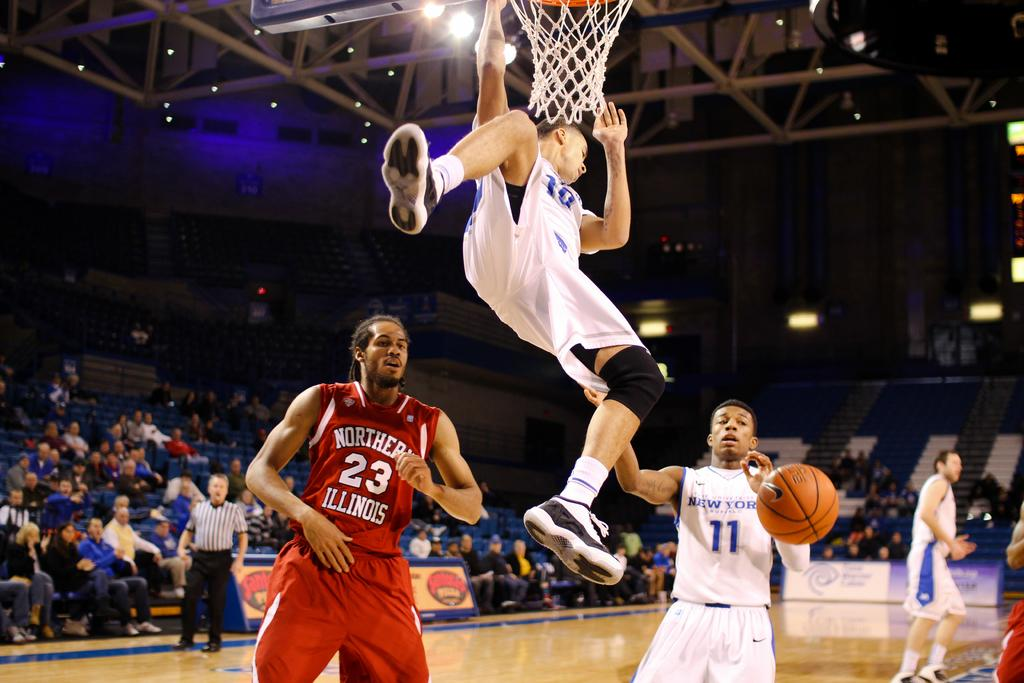<image>
Give a short and clear explanation of the subsequent image. a person standing with the number 11 on it 